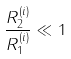Convert formula to latex. <formula><loc_0><loc_0><loc_500><loc_500>\frac { R _ { 2 } ^ { ( i ) } } { R _ { 1 } ^ { ( i ) } } \ll 1</formula> 